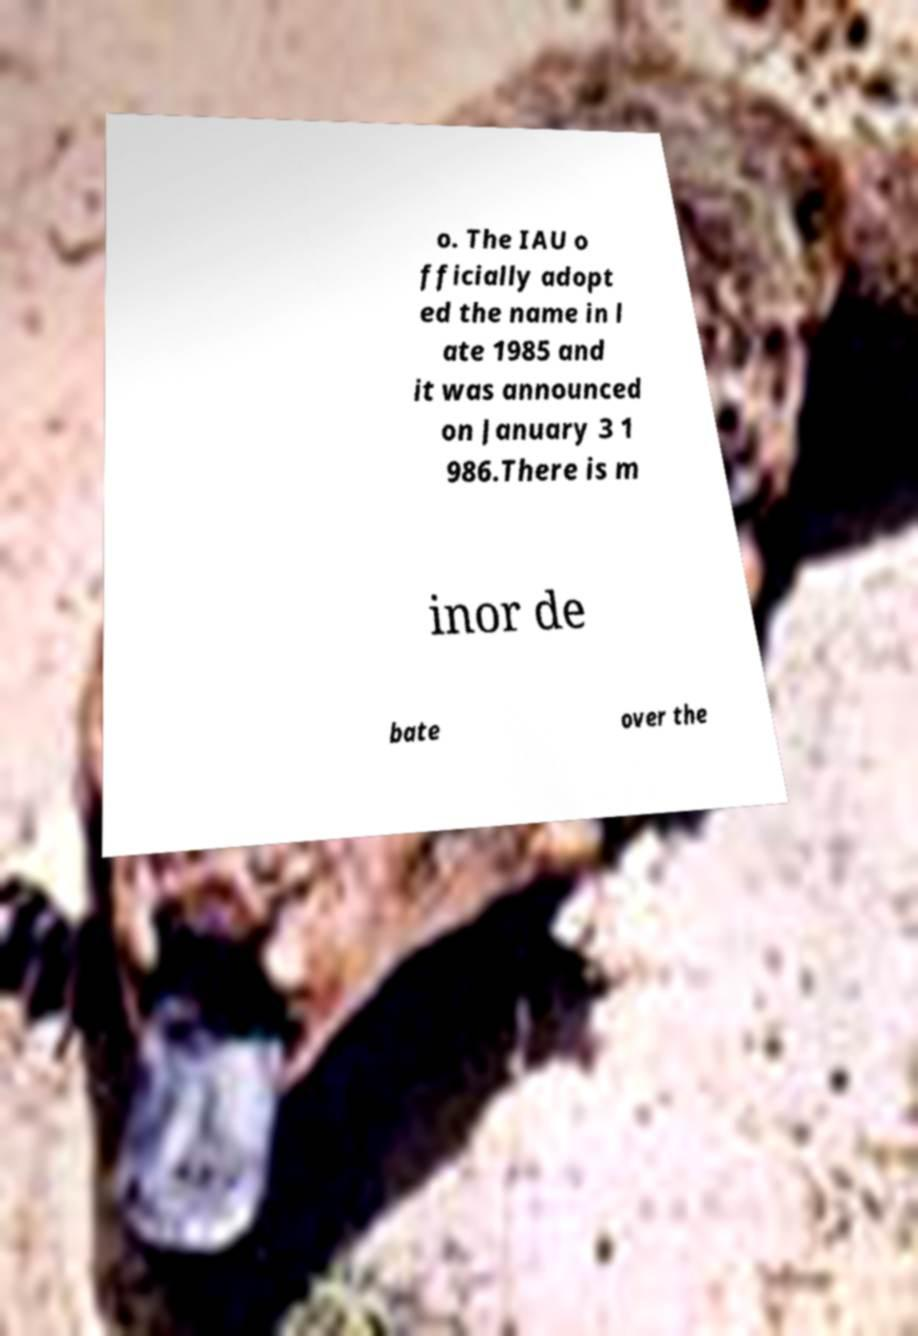Please identify and transcribe the text found in this image. o. The IAU o fficially adopt ed the name in l ate 1985 and it was announced on January 3 1 986.There is m inor de bate over the 